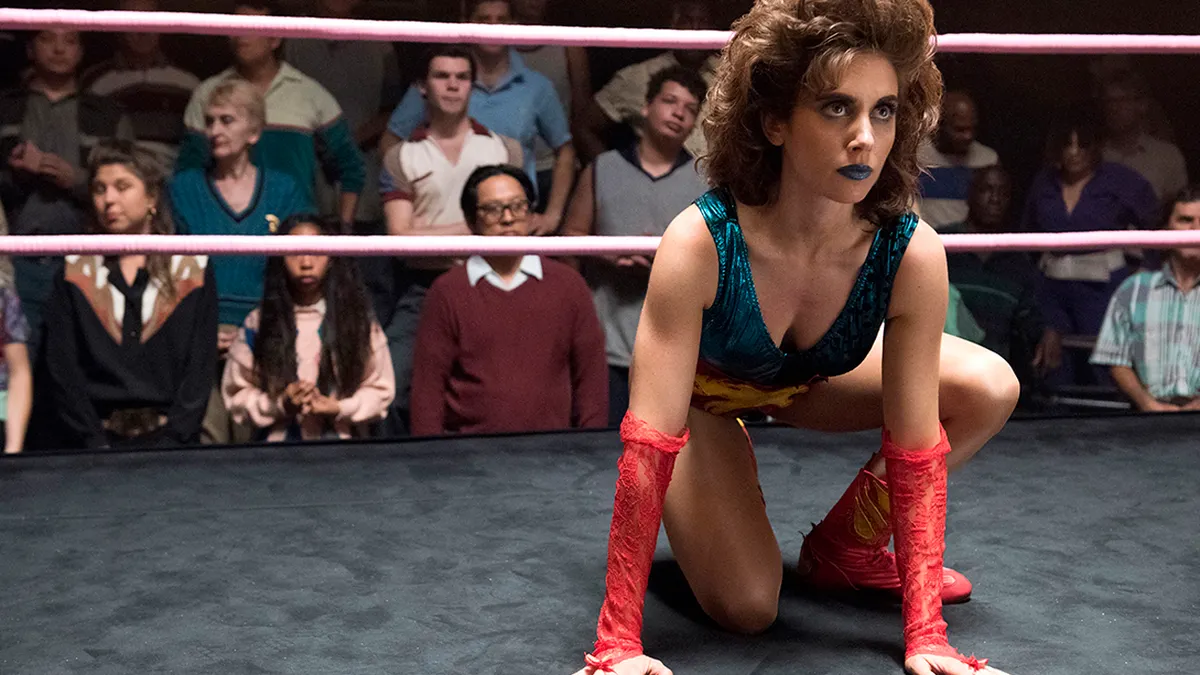What emotions seem to be reflected by the audience? The audience in the background reflects a spectrum of emotions, from rapt attention to visible excitement. Some lean forward, eyes wide, captivated by the spectacle, while others have expressions of thrill or suspense, awaiting the next decisive moment in the match. 